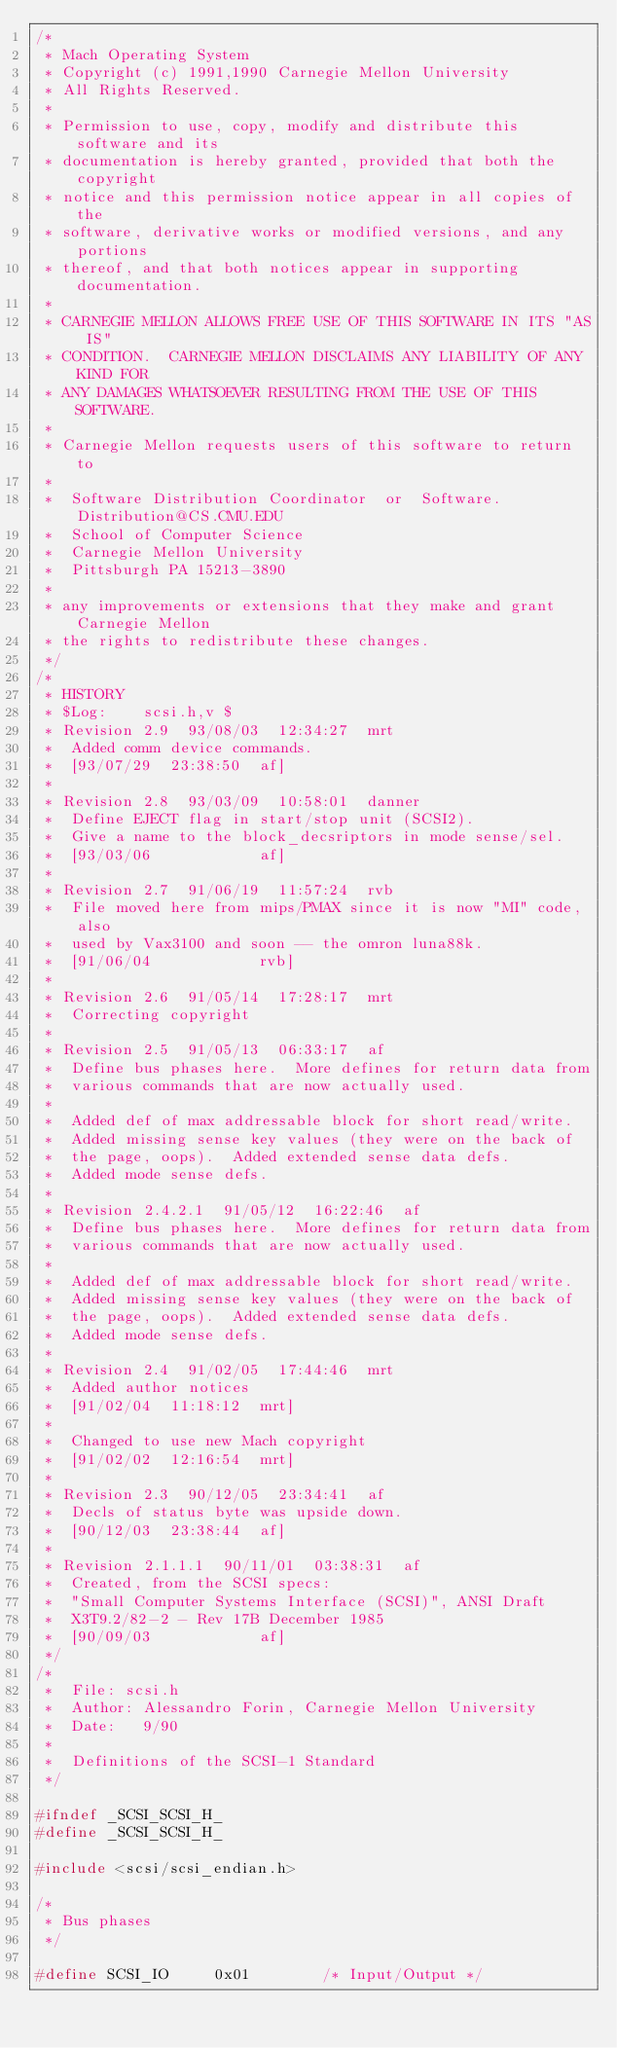Convert code to text. <code><loc_0><loc_0><loc_500><loc_500><_C_>/* 
 * Mach Operating System
 * Copyright (c) 1991,1990 Carnegie Mellon University
 * All Rights Reserved.
 * 
 * Permission to use, copy, modify and distribute this software and its
 * documentation is hereby granted, provided that both the copyright
 * notice and this permission notice appear in all copies of the
 * software, derivative works or modified versions, and any portions
 * thereof, and that both notices appear in supporting documentation.
 * 
 * CARNEGIE MELLON ALLOWS FREE USE OF THIS SOFTWARE IN ITS "AS IS"
 * CONDITION.  CARNEGIE MELLON DISCLAIMS ANY LIABILITY OF ANY KIND FOR
 * ANY DAMAGES WHATSOEVER RESULTING FROM THE USE OF THIS SOFTWARE.
 * 
 * Carnegie Mellon requests users of this software to return to
 * 
 *  Software Distribution Coordinator  or  Software.Distribution@CS.CMU.EDU
 *  School of Computer Science
 *  Carnegie Mellon University
 *  Pittsburgh PA 15213-3890
 * 
 * any improvements or extensions that they make and grant Carnegie Mellon
 * the rights to redistribute these changes.
 */
/*
 * HISTORY
 * $Log:	scsi.h,v $
 * Revision 2.9  93/08/03  12:34:27  mrt
 * 	Added comm device commands.
 * 	[93/07/29  23:38:50  af]
 * 
 * Revision 2.8  93/03/09  10:58:01  danner
 * 	Define EJECT flag in start/stop unit (SCSI2).
 * 	Give a name to the block_decsriptors in mode sense/sel.
 * 	[93/03/06            af]
 * 
 * Revision 2.7  91/06/19  11:57:24  rvb
 * 	File moved here from mips/PMAX since it is now "MI" code, also
 * 	used by Vax3100 and soon -- the omron luna88k.
 * 	[91/06/04            rvb]
 * 
 * Revision 2.6  91/05/14  17:28:17  mrt
 * 	Correcting copyright
 * 
 * Revision 2.5  91/05/13  06:33:17  af
 * 	Define bus phases here.  More defines for return data from
 * 	various commands that are now actually used.
 * 
 * 	Added def of max addressable block for short read/write.
 * 	Added missing sense key values (they were on the back of
 * 	the page, oops).  Added extended sense data defs.
 * 	Added mode sense defs.
 * 
 * Revision 2.4.2.1  91/05/12  16:22:46  af
 * 	Define bus phases here.  More defines for return data from
 * 	various commands that are now actually used.
 * 
 * 	Added def of max addressable block for short read/write.
 * 	Added missing sense key values (they were on the back of
 * 	the page, oops).  Added extended sense data defs.
 * 	Added mode sense defs.
 * 
 * Revision 2.4  91/02/05  17:44:46  mrt
 * 	Added author notices
 * 	[91/02/04  11:18:12  mrt]
 * 
 * 	Changed to use new Mach copyright
 * 	[91/02/02  12:16:54  mrt]
 * 
 * Revision 2.3  90/12/05  23:34:41  af
 * 	Decls of status byte was upside down.
 * 	[90/12/03  23:38:44  af]
 * 
 * Revision 2.1.1.1  90/11/01  03:38:31  af
 * 	Created, from the SCSI specs:
 * 	"Small Computer Systems Interface (SCSI)", ANSI Draft
 * 	X3T9.2/82-2 - Rev 17B December 1985
 * 	[90/09/03            af]
 */
/*
 *	File: scsi.h
 * 	Author: Alessandro Forin, Carnegie Mellon University
 *	Date:	9/90
 *
 *	Definitions of the SCSI-1 Standard
 */

#ifndef	_SCSI_SCSI_H_
#define	_SCSI_SCSI_H_

#include <scsi/scsi_endian.h>

/*
 * Bus phases
 */

#define	SCSI_IO		0x01		/* Input/Output */</code> 